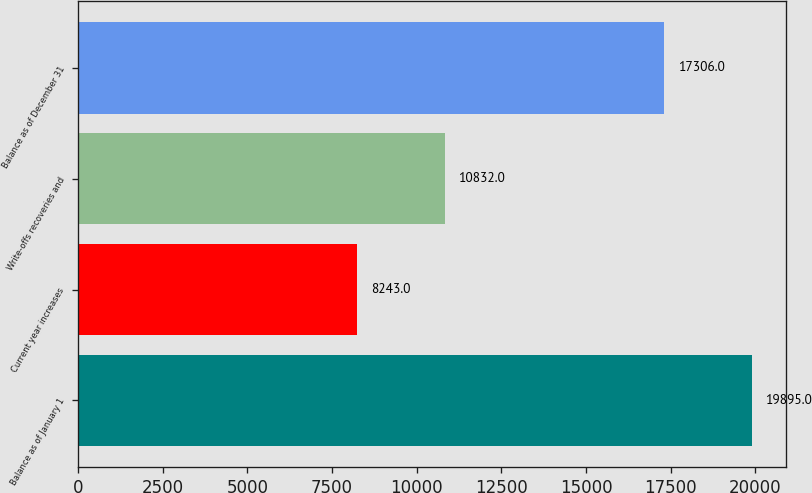Convert chart. <chart><loc_0><loc_0><loc_500><loc_500><bar_chart><fcel>Balance as of January 1<fcel>Current year increases<fcel>Write-offs recoveries and<fcel>Balance as of December 31<nl><fcel>19895<fcel>8243<fcel>10832<fcel>17306<nl></chart> 